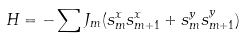Convert formula to latex. <formula><loc_0><loc_0><loc_500><loc_500>H = - \sum J _ { m } ( s _ { m } ^ { x } s _ { m + 1 } ^ { x } + s _ { m } ^ { y } s _ { m + 1 } ^ { y } )</formula> 